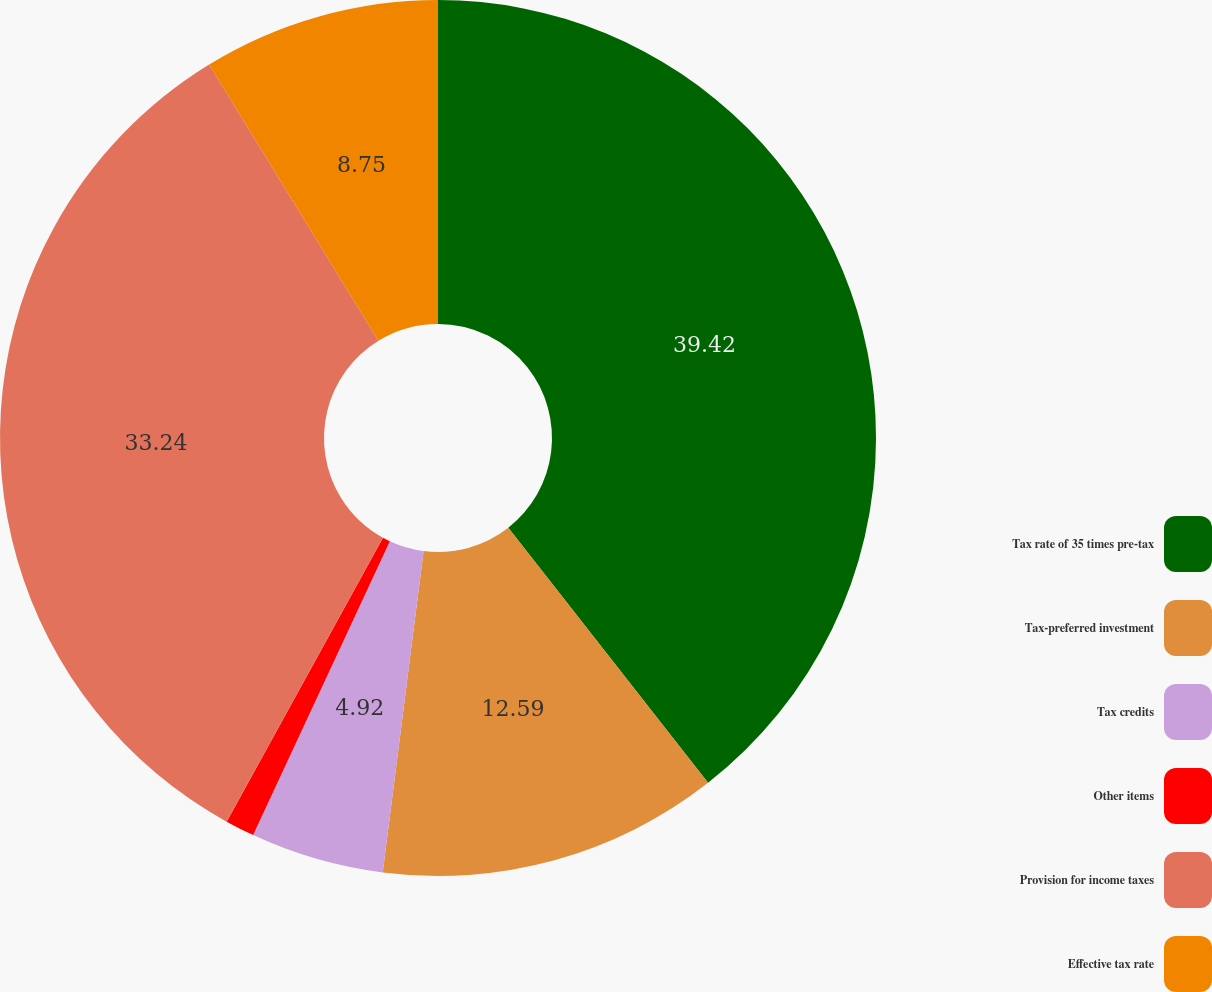Convert chart to OTSL. <chart><loc_0><loc_0><loc_500><loc_500><pie_chart><fcel>Tax rate of 35 times pre-tax<fcel>Tax-preferred investment<fcel>Tax credits<fcel>Other items<fcel>Provision for income taxes<fcel>Effective tax rate<nl><fcel>39.43%<fcel>12.59%<fcel>4.92%<fcel>1.08%<fcel>33.24%<fcel>8.75%<nl></chart> 